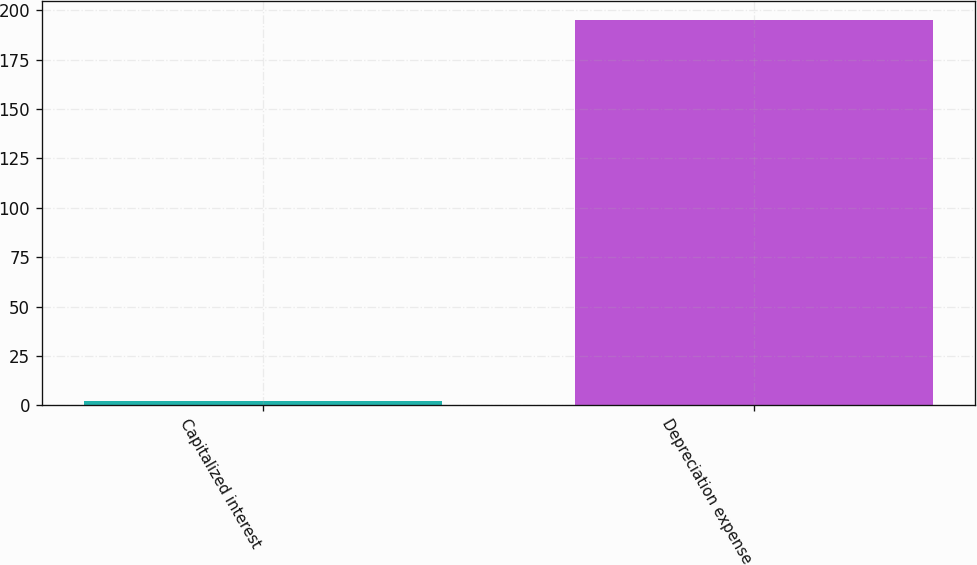<chart> <loc_0><loc_0><loc_500><loc_500><bar_chart><fcel>Capitalized interest<fcel>Depreciation expense<nl><fcel>2<fcel>195<nl></chart> 